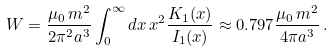Convert formula to latex. <formula><loc_0><loc_0><loc_500><loc_500>W = \frac { \mu _ { 0 } \, m ^ { 2 } } { 2 \pi ^ { 2 } a ^ { 3 } } \int _ { 0 } ^ { \infty } d x \, x ^ { 2 } \frac { K _ { 1 } ( x ) } { I _ { 1 } ( x ) } \approx 0 . 7 9 7 \frac { \mu _ { 0 } \, m ^ { 2 } } { 4 \pi a ^ { 3 } } \, .</formula> 